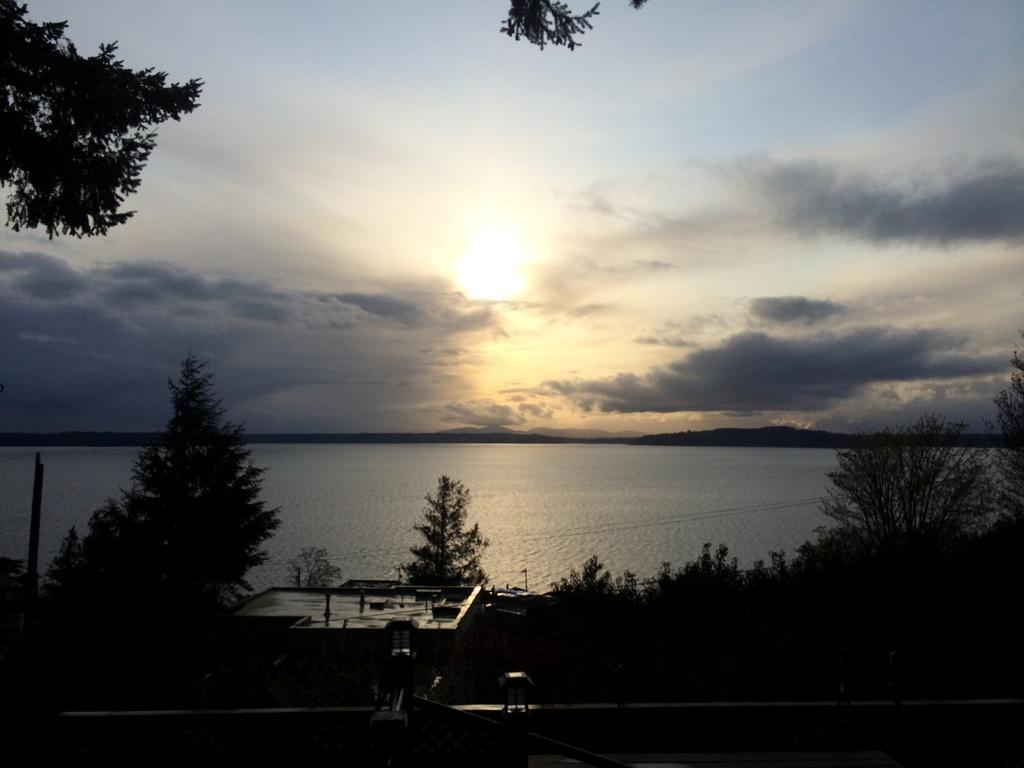What is the color scheme of the image? The image is black and white. What type of natural environment is depicted in the image? There are trees and water in the image, suggesting a natural setting. What type of geographical feature is present in the image? There are mountains in the image. What type of man-made structure is present in the image? There is a building in the image. What is visible in the background of the image? The sky is visible in the background of the image, with clouds present. What type of bells can be heard ringing in the image? There are no bells present in the image, and therefore no sound can be heard. What type of iron is used to construct the building in the image? There is no information about the materials used to construct the building in the image. 